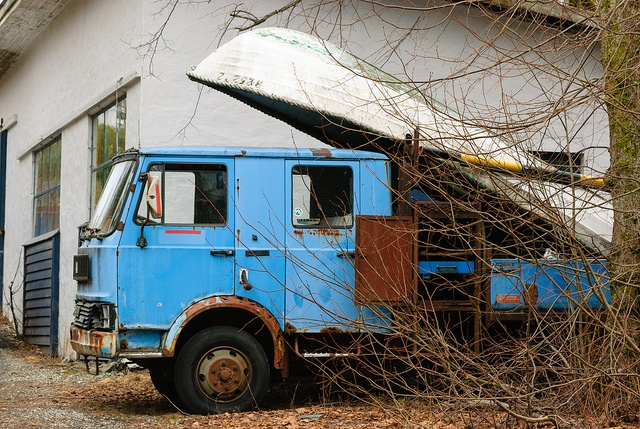Describe the objects in this image and their specific colors. I can see truck in white, black, lightblue, and maroon tones and boat in white, black, darkgray, and maroon tones in this image. 